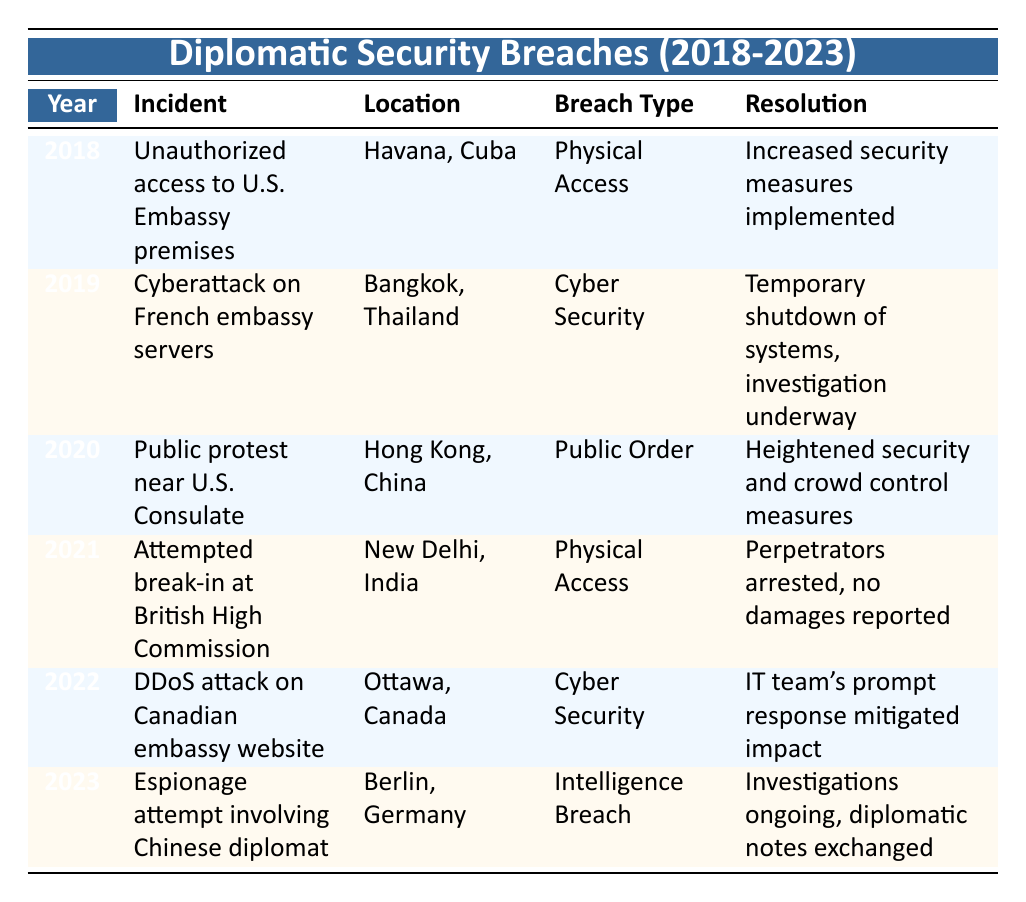What incident occurred in 2020? According to the table, the incident for the year 2020 is "Public protest near U.S. Consulate."
Answer: Public protest near U.S. Consulate How many incidents involved physical access breaches? The table shows two incidents involving physical access breaches: (1) Unauthorized access to U.S. Embassy premises in 2018 and (2) Attempted break-in at the British High Commission in 2021. Thus, the total is 2.
Answer: 2 Was there a cyber security incident recorded in 2022? The table lists the incident for 2022 as a DDoS attack on the Canadian embassy website, which qualifies as a cyber security incident. Therefore, the answer is yes.
Answer: Yes What was the resolution for the espionage attempt in 2023? The resolution for the espionage attempt involving a Chinese diplomat in 2023 was "Investigations ongoing, diplomatic notes exchanged," as noted in the table.
Answer: Investigations ongoing, diplomatic notes exchanged In which year did the highest number of incidents occur? The table shows one incident per year from 2018 to 2023, thus the highest number of incidents in any given year is 1, which applies to all listed years.
Answer: 1 